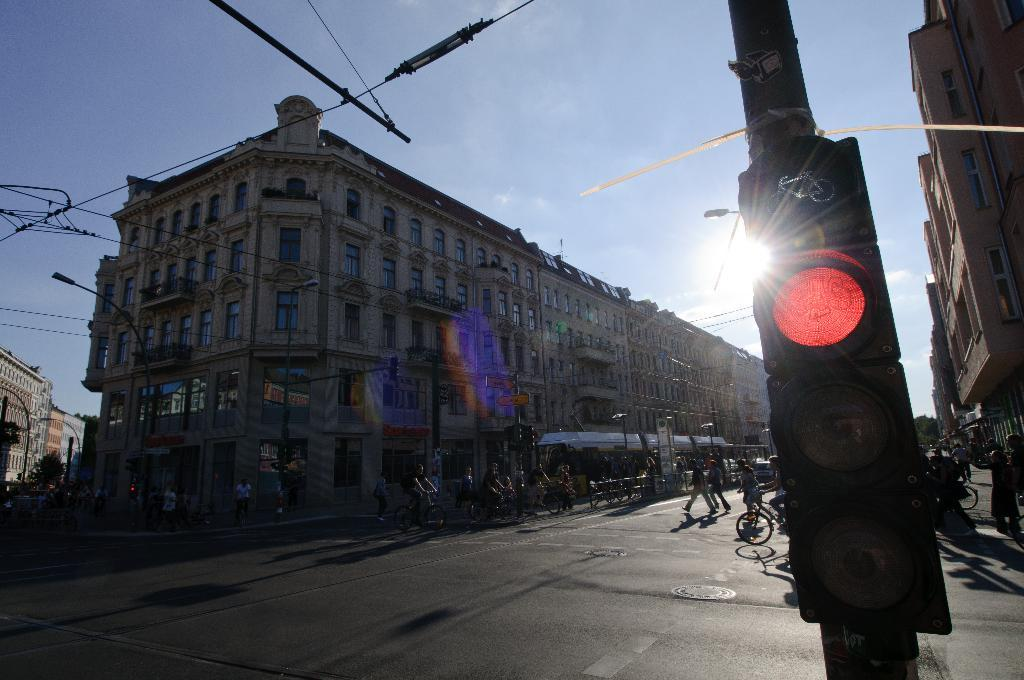What is the main object in the image that controls traffic? There is a traffic light in the image that controls traffic. What mode of transportation can be seen in the image? There are bicycles and a vehicle on the road in the image. What type of structures are visible in the image? There are buildings in the image. What can be seen in the background of the image? The sky is visible in the background of the image, and the sun is observable in the sky. What type of war is being fought in the image? There is no war present in the image; it features a traffic light, bicycles, a vehicle, buildings, the sky, and the sun. How do the bicycles show respect to the traffic light in the image? The image does not depict any interaction between the bicycles and the traffic light, nor does it show any indication of respect. 